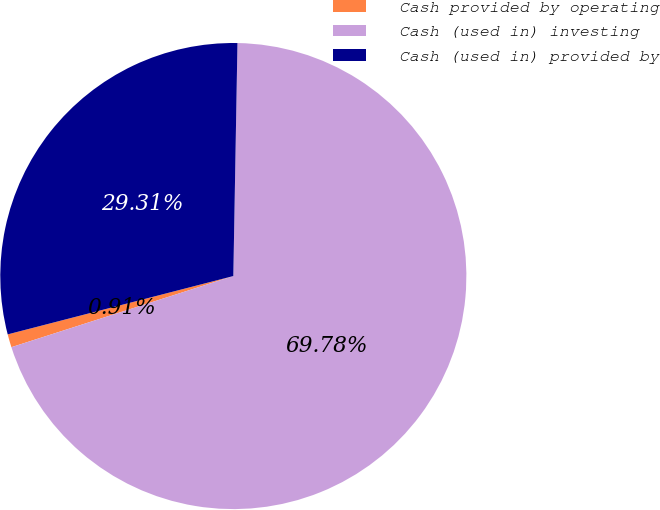Convert chart. <chart><loc_0><loc_0><loc_500><loc_500><pie_chart><fcel>Cash provided by operating<fcel>Cash (used in) investing<fcel>Cash (used in) provided by<nl><fcel>0.91%<fcel>69.78%<fcel>29.31%<nl></chart> 